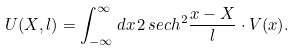Convert formula to latex. <formula><loc_0><loc_0><loc_500><loc_500>U ( X , l ) = \int _ { - \infty } ^ { \infty } d x \, 2 \, s e c h ^ { 2 } \frac { x - X } { l } \cdot V ( x ) .</formula> 